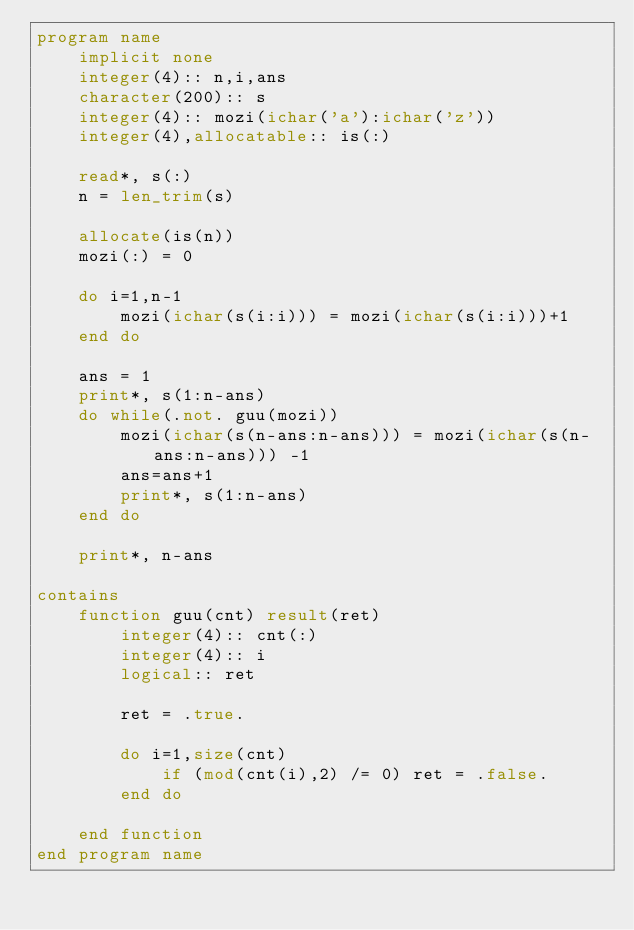Convert code to text. <code><loc_0><loc_0><loc_500><loc_500><_FORTRAN_>program name
    implicit none
    integer(4):: n,i,ans
    character(200):: s
    integer(4):: mozi(ichar('a'):ichar('z'))
    integer(4),allocatable:: is(:)

    read*, s(:)
    n = len_trim(s)

    allocate(is(n))
    mozi(:) = 0

    do i=1,n-1
        mozi(ichar(s(i:i))) = mozi(ichar(s(i:i)))+1
    end do

    ans = 1
    print*, s(1:n-ans)
    do while(.not. guu(mozi))
        mozi(ichar(s(n-ans:n-ans))) = mozi(ichar(s(n-ans:n-ans))) -1
        ans=ans+1
        print*, s(1:n-ans)
    end do

    print*, n-ans
    
contains
    function guu(cnt) result(ret)
        integer(4):: cnt(:)
        integer(4):: i
        logical:: ret

        ret = .true.

        do i=1,size(cnt)
            if (mod(cnt(i),2) /= 0) ret = .false.
        end do

    end function
end program name</code> 